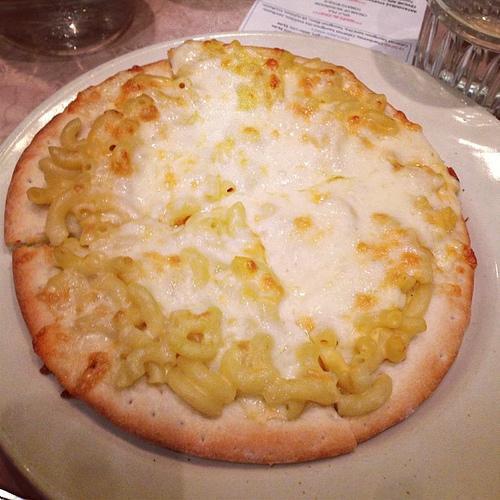How many different toppings are on the pizza?
Give a very brief answer. 2. 